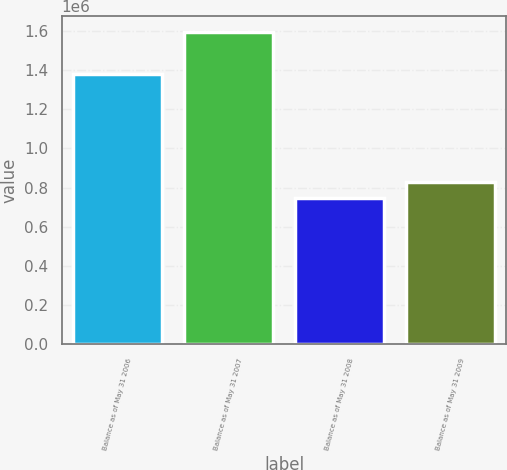Convert chart to OTSL. <chart><loc_0><loc_0><loc_500><loc_500><bar_chart><fcel>Balance as of May 31 2006<fcel>Balance as of May 31 2007<fcel>Balance as of May 31 2008<fcel>Balance as of May 31 2009<nl><fcel>1.38097e+06<fcel>1.5951e+06<fcel>745351<fcel>830326<nl></chart> 